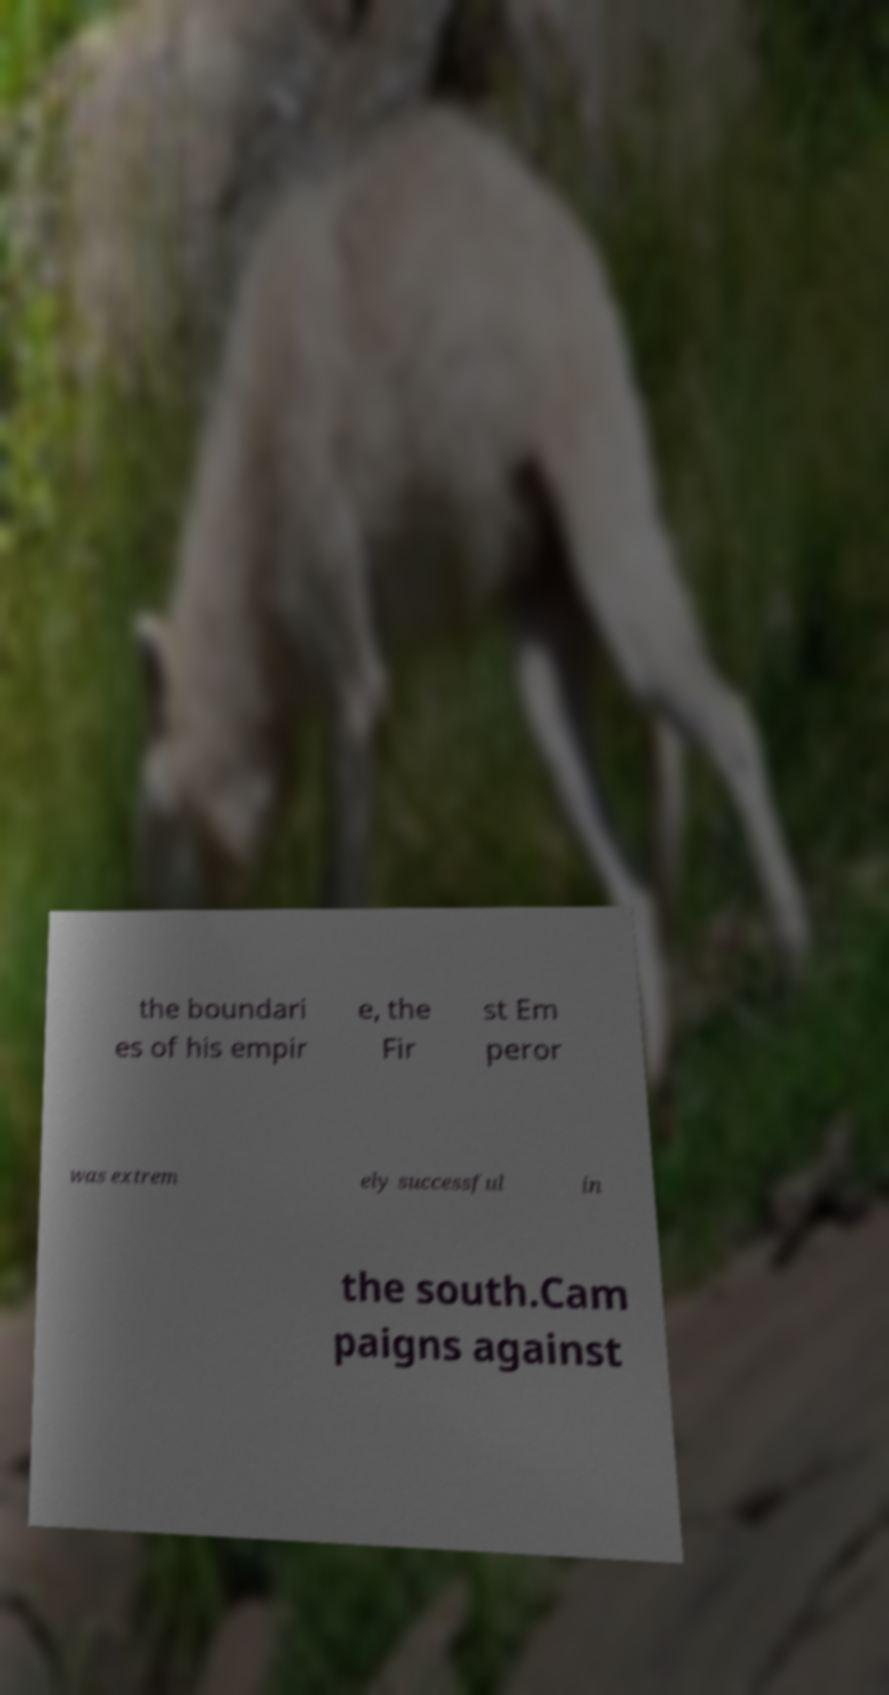Could you assist in decoding the text presented in this image and type it out clearly? the boundari es of his empir e, the Fir st Em peror was extrem ely successful in the south.Cam paigns against 